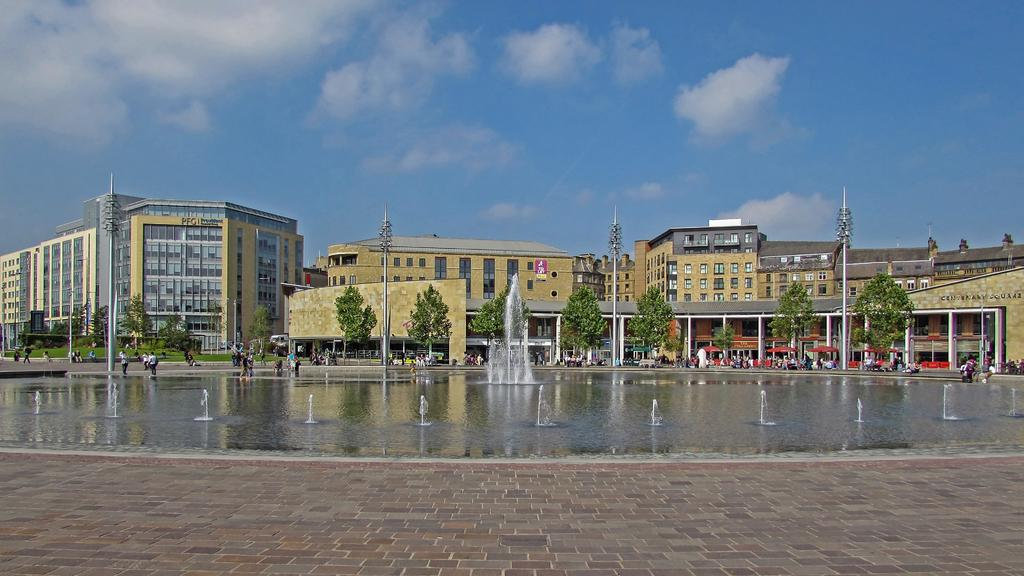What type of surface can be seen in the image? Ground is visible in the image. What natural element is present in the image? There is water in the image. What structure can be seen in the image? There is a fountain in the image. What type of lighting is present in the image? Light poles are present in the image. What type of vegetation is visible in the image? Trees are visible in the image. What activity are people engaged in within the image? People are walking on the road in the image. What type of man-made structures are visible in the image? There are buildings in the image. What is the color of the sky in the background of the image? The sky is blue in the background of the image. What atmospheric feature is visible in the sky? Clouds are visible in the sky. What type of fruit is being kicked around by the people in the image? There is no fruit present in the image, nor are people kicking anything around. 